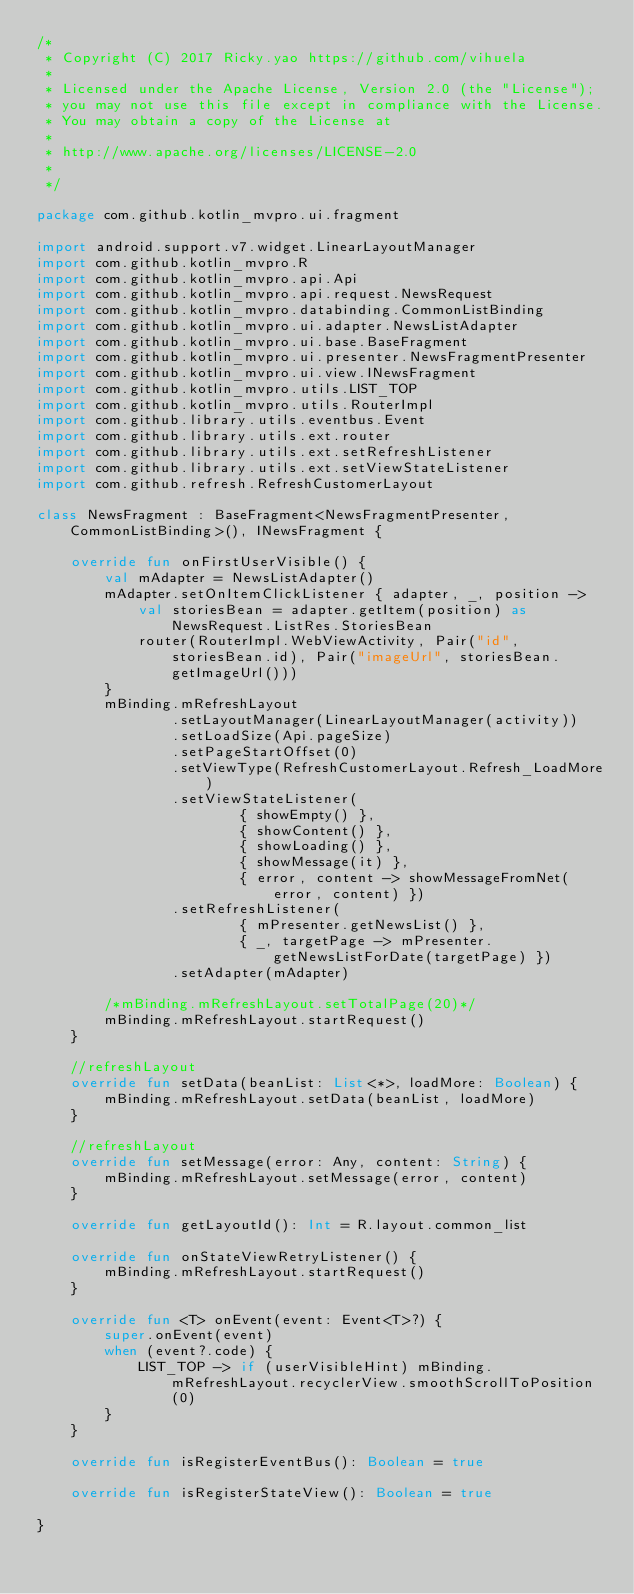Convert code to text. <code><loc_0><loc_0><loc_500><loc_500><_Kotlin_>/*
 * Copyright (C) 2017 Ricky.yao https://github.com/vihuela
 *
 * Licensed under the Apache License, Version 2.0 (the "License");
 * you may not use this file except in compliance with the License.
 * You may obtain a copy of the License at
 *
 * http://www.apache.org/licenses/LICENSE-2.0
 *
 */

package com.github.kotlin_mvpro.ui.fragment

import android.support.v7.widget.LinearLayoutManager
import com.github.kotlin_mvpro.R
import com.github.kotlin_mvpro.api.Api
import com.github.kotlin_mvpro.api.request.NewsRequest
import com.github.kotlin_mvpro.databinding.CommonListBinding
import com.github.kotlin_mvpro.ui.adapter.NewsListAdapter
import com.github.kotlin_mvpro.ui.base.BaseFragment
import com.github.kotlin_mvpro.ui.presenter.NewsFragmentPresenter
import com.github.kotlin_mvpro.ui.view.INewsFragment
import com.github.kotlin_mvpro.utils.LIST_TOP
import com.github.kotlin_mvpro.utils.RouterImpl
import com.github.library.utils.eventbus.Event
import com.github.library.utils.ext.router
import com.github.library.utils.ext.setRefreshListener
import com.github.library.utils.ext.setViewStateListener
import com.github.refresh.RefreshCustomerLayout

class NewsFragment : BaseFragment<NewsFragmentPresenter, CommonListBinding>(), INewsFragment {

    override fun onFirstUserVisible() {
        val mAdapter = NewsListAdapter()
        mAdapter.setOnItemClickListener { adapter, _, position ->
            val storiesBean = adapter.getItem(position) as NewsRequest.ListRes.StoriesBean
            router(RouterImpl.WebViewActivity, Pair("id", storiesBean.id), Pair("imageUrl", storiesBean.getImageUrl()))
        }
        mBinding.mRefreshLayout
                .setLayoutManager(LinearLayoutManager(activity))
                .setLoadSize(Api.pageSize)
                .setPageStartOffset(0)
                .setViewType(RefreshCustomerLayout.Refresh_LoadMore)
                .setViewStateListener(
                        { showEmpty() },
                        { showContent() },
                        { showLoading() },
                        { showMessage(it) },
                        { error, content -> showMessageFromNet(error, content) })
                .setRefreshListener(
                        { mPresenter.getNewsList() },
                        { _, targetPage -> mPresenter.getNewsListForDate(targetPage) })
                .setAdapter(mAdapter)

        /*mBinding.mRefreshLayout.setTotalPage(20)*/
        mBinding.mRefreshLayout.startRequest()
    }

    //refreshLayout
    override fun setData(beanList: List<*>, loadMore: Boolean) {
        mBinding.mRefreshLayout.setData(beanList, loadMore)
    }

    //refreshLayout
    override fun setMessage(error: Any, content: String) {
        mBinding.mRefreshLayout.setMessage(error, content)
    }

    override fun getLayoutId(): Int = R.layout.common_list

    override fun onStateViewRetryListener() {
        mBinding.mRefreshLayout.startRequest()
    }

    override fun <T> onEvent(event: Event<T>?) {
        super.onEvent(event)
        when (event?.code) {
            LIST_TOP -> if (userVisibleHint) mBinding.mRefreshLayout.recyclerView.smoothScrollToPosition(0)
        }
    }

    override fun isRegisterEventBus(): Boolean = true

    override fun isRegisterStateView(): Boolean = true

}</code> 